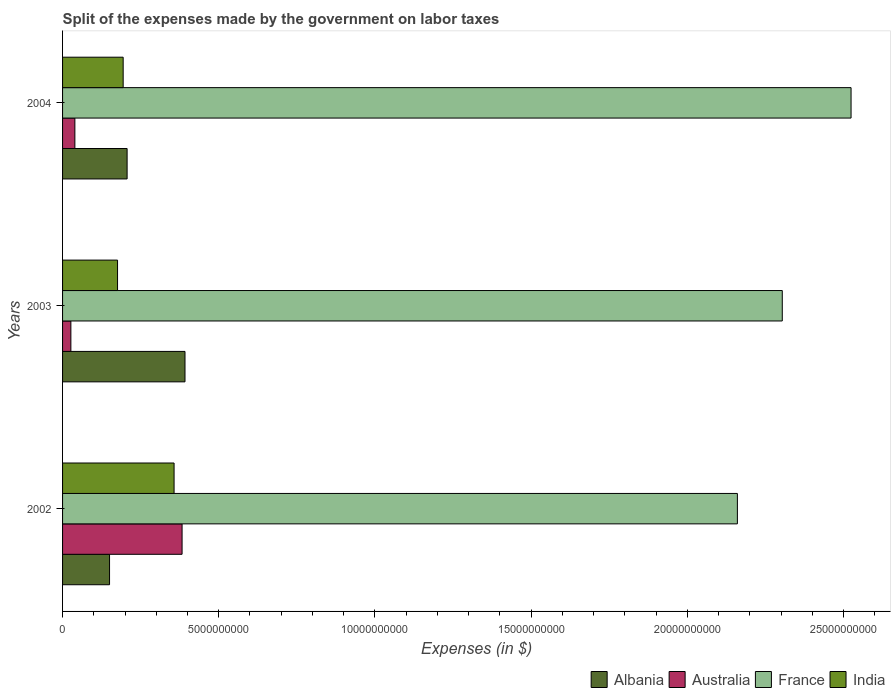How many different coloured bars are there?
Provide a short and direct response. 4. Are the number of bars per tick equal to the number of legend labels?
Offer a very short reply. Yes. Are the number of bars on each tick of the Y-axis equal?
Your response must be concise. Yes. How many bars are there on the 2nd tick from the bottom?
Offer a terse response. 4. What is the label of the 2nd group of bars from the top?
Offer a terse response. 2003. In how many cases, is the number of bars for a given year not equal to the number of legend labels?
Your answer should be compact. 0. What is the expenses made by the government on labor taxes in France in 2002?
Give a very brief answer. 2.16e+1. Across all years, what is the maximum expenses made by the government on labor taxes in France?
Offer a terse response. 2.52e+1. Across all years, what is the minimum expenses made by the government on labor taxes in Albania?
Your answer should be compact. 1.50e+09. In which year was the expenses made by the government on labor taxes in India maximum?
Ensure brevity in your answer.  2002. In which year was the expenses made by the government on labor taxes in Albania minimum?
Provide a short and direct response. 2002. What is the total expenses made by the government on labor taxes in Albania in the graph?
Ensure brevity in your answer.  7.49e+09. What is the difference between the expenses made by the government on labor taxes in India in 2002 and that in 2003?
Ensure brevity in your answer.  1.81e+09. What is the difference between the expenses made by the government on labor taxes in Australia in 2004 and the expenses made by the government on labor taxes in Albania in 2003?
Give a very brief answer. -3.53e+09. What is the average expenses made by the government on labor taxes in Albania per year?
Give a very brief answer. 2.50e+09. In the year 2002, what is the difference between the expenses made by the government on labor taxes in Albania and expenses made by the government on labor taxes in France?
Make the answer very short. -2.01e+1. In how many years, is the expenses made by the government on labor taxes in Albania greater than 17000000000 $?
Ensure brevity in your answer.  0. What is the ratio of the expenses made by the government on labor taxes in Australia in 2003 to that in 2004?
Ensure brevity in your answer.  0.68. Is the difference between the expenses made by the government on labor taxes in Albania in 2002 and 2003 greater than the difference between the expenses made by the government on labor taxes in France in 2002 and 2003?
Provide a short and direct response. No. What is the difference between the highest and the second highest expenses made by the government on labor taxes in Albania?
Your answer should be very brief. 1.85e+09. What is the difference between the highest and the lowest expenses made by the government on labor taxes in Australia?
Offer a very short reply. 3.56e+09. Is the sum of the expenses made by the government on labor taxes in Albania in 2003 and 2004 greater than the maximum expenses made by the government on labor taxes in Australia across all years?
Your answer should be compact. Yes. Is it the case that in every year, the sum of the expenses made by the government on labor taxes in India and expenses made by the government on labor taxes in France is greater than the sum of expenses made by the government on labor taxes in Australia and expenses made by the government on labor taxes in Albania?
Your answer should be compact. No. What does the 4th bar from the top in 2002 represents?
Your answer should be very brief. Albania. What does the 3rd bar from the bottom in 2002 represents?
Offer a terse response. France. How many bars are there?
Offer a very short reply. 12. How many years are there in the graph?
Provide a succinct answer. 3. What is the difference between two consecutive major ticks on the X-axis?
Provide a succinct answer. 5.00e+09. Are the values on the major ticks of X-axis written in scientific E-notation?
Provide a short and direct response. No. Does the graph contain any zero values?
Keep it short and to the point. No. Does the graph contain grids?
Your answer should be very brief. No. Where does the legend appear in the graph?
Make the answer very short. Bottom right. How many legend labels are there?
Make the answer very short. 4. How are the legend labels stacked?
Your answer should be compact. Horizontal. What is the title of the graph?
Provide a short and direct response. Split of the expenses made by the government on labor taxes. Does "Nicaragua" appear as one of the legend labels in the graph?
Provide a succinct answer. No. What is the label or title of the X-axis?
Ensure brevity in your answer.  Expenses (in $). What is the label or title of the Y-axis?
Ensure brevity in your answer.  Years. What is the Expenses (in $) of Albania in 2002?
Offer a very short reply. 1.50e+09. What is the Expenses (in $) in Australia in 2002?
Your response must be concise. 3.83e+09. What is the Expenses (in $) of France in 2002?
Give a very brief answer. 2.16e+1. What is the Expenses (in $) of India in 2002?
Your answer should be very brief. 3.57e+09. What is the Expenses (in $) in Albania in 2003?
Offer a terse response. 3.92e+09. What is the Expenses (in $) of Australia in 2003?
Your answer should be very brief. 2.66e+08. What is the Expenses (in $) of France in 2003?
Your response must be concise. 2.30e+1. What is the Expenses (in $) of India in 2003?
Ensure brevity in your answer.  1.76e+09. What is the Expenses (in $) in Albania in 2004?
Ensure brevity in your answer.  2.07e+09. What is the Expenses (in $) of Australia in 2004?
Offer a very short reply. 3.94e+08. What is the Expenses (in $) in France in 2004?
Your response must be concise. 2.52e+1. What is the Expenses (in $) in India in 2004?
Provide a short and direct response. 1.94e+09. Across all years, what is the maximum Expenses (in $) in Albania?
Offer a very short reply. 3.92e+09. Across all years, what is the maximum Expenses (in $) of Australia?
Ensure brevity in your answer.  3.83e+09. Across all years, what is the maximum Expenses (in $) in France?
Offer a very short reply. 2.52e+1. Across all years, what is the maximum Expenses (in $) of India?
Your answer should be compact. 3.57e+09. Across all years, what is the minimum Expenses (in $) in Albania?
Your response must be concise. 1.50e+09. Across all years, what is the minimum Expenses (in $) in Australia?
Offer a very short reply. 2.66e+08. Across all years, what is the minimum Expenses (in $) in France?
Your response must be concise. 2.16e+1. Across all years, what is the minimum Expenses (in $) of India?
Ensure brevity in your answer.  1.76e+09. What is the total Expenses (in $) in Albania in the graph?
Give a very brief answer. 7.49e+09. What is the total Expenses (in $) of Australia in the graph?
Your response must be concise. 4.49e+09. What is the total Expenses (in $) in France in the graph?
Offer a very short reply. 6.99e+1. What is the total Expenses (in $) in India in the graph?
Your answer should be compact. 7.27e+09. What is the difference between the Expenses (in $) of Albania in 2002 and that in 2003?
Offer a very short reply. -2.42e+09. What is the difference between the Expenses (in $) of Australia in 2002 and that in 2003?
Your answer should be compact. 3.56e+09. What is the difference between the Expenses (in $) of France in 2002 and that in 2003?
Give a very brief answer. -1.44e+09. What is the difference between the Expenses (in $) in India in 2002 and that in 2003?
Your response must be concise. 1.81e+09. What is the difference between the Expenses (in $) of Albania in 2002 and that in 2004?
Make the answer very short. -5.62e+08. What is the difference between the Expenses (in $) in Australia in 2002 and that in 2004?
Provide a short and direct response. 3.43e+09. What is the difference between the Expenses (in $) of France in 2002 and that in 2004?
Keep it short and to the point. -3.64e+09. What is the difference between the Expenses (in $) in India in 2002 and that in 2004?
Your answer should be compact. 1.63e+09. What is the difference between the Expenses (in $) of Albania in 2003 and that in 2004?
Your response must be concise. 1.85e+09. What is the difference between the Expenses (in $) in Australia in 2003 and that in 2004?
Provide a short and direct response. -1.28e+08. What is the difference between the Expenses (in $) in France in 2003 and that in 2004?
Provide a short and direct response. -2.20e+09. What is the difference between the Expenses (in $) of India in 2003 and that in 2004?
Keep it short and to the point. -1.80e+08. What is the difference between the Expenses (in $) of Albania in 2002 and the Expenses (in $) of Australia in 2003?
Offer a terse response. 1.24e+09. What is the difference between the Expenses (in $) of Albania in 2002 and the Expenses (in $) of France in 2003?
Give a very brief answer. -2.15e+1. What is the difference between the Expenses (in $) of Albania in 2002 and the Expenses (in $) of India in 2003?
Offer a very short reply. -2.56e+08. What is the difference between the Expenses (in $) of Australia in 2002 and the Expenses (in $) of France in 2003?
Keep it short and to the point. -1.92e+1. What is the difference between the Expenses (in $) in Australia in 2002 and the Expenses (in $) in India in 2003?
Make the answer very short. 2.07e+09. What is the difference between the Expenses (in $) of France in 2002 and the Expenses (in $) of India in 2003?
Your answer should be compact. 1.98e+1. What is the difference between the Expenses (in $) in Albania in 2002 and the Expenses (in $) in Australia in 2004?
Give a very brief answer. 1.11e+09. What is the difference between the Expenses (in $) of Albania in 2002 and the Expenses (in $) of France in 2004?
Ensure brevity in your answer.  -2.37e+1. What is the difference between the Expenses (in $) in Albania in 2002 and the Expenses (in $) in India in 2004?
Make the answer very short. -4.36e+08. What is the difference between the Expenses (in $) in Australia in 2002 and the Expenses (in $) in France in 2004?
Your response must be concise. -2.14e+1. What is the difference between the Expenses (in $) in Australia in 2002 and the Expenses (in $) in India in 2004?
Give a very brief answer. 1.89e+09. What is the difference between the Expenses (in $) of France in 2002 and the Expenses (in $) of India in 2004?
Your answer should be compact. 1.97e+1. What is the difference between the Expenses (in $) of Albania in 2003 and the Expenses (in $) of Australia in 2004?
Provide a short and direct response. 3.53e+09. What is the difference between the Expenses (in $) in Albania in 2003 and the Expenses (in $) in France in 2004?
Provide a succinct answer. -2.13e+1. What is the difference between the Expenses (in $) in Albania in 2003 and the Expenses (in $) in India in 2004?
Your response must be concise. 1.98e+09. What is the difference between the Expenses (in $) of Australia in 2003 and the Expenses (in $) of France in 2004?
Provide a succinct answer. -2.50e+1. What is the difference between the Expenses (in $) in Australia in 2003 and the Expenses (in $) in India in 2004?
Keep it short and to the point. -1.67e+09. What is the difference between the Expenses (in $) in France in 2003 and the Expenses (in $) in India in 2004?
Provide a succinct answer. 2.11e+1. What is the average Expenses (in $) of Albania per year?
Ensure brevity in your answer.  2.50e+09. What is the average Expenses (in $) in Australia per year?
Provide a succinct answer. 1.50e+09. What is the average Expenses (in $) in France per year?
Offer a very short reply. 2.33e+1. What is the average Expenses (in $) in India per year?
Your response must be concise. 2.42e+09. In the year 2002, what is the difference between the Expenses (in $) of Albania and Expenses (in $) of Australia?
Provide a short and direct response. -2.32e+09. In the year 2002, what is the difference between the Expenses (in $) of Albania and Expenses (in $) of France?
Your response must be concise. -2.01e+1. In the year 2002, what is the difference between the Expenses (in $) in Albania and Expenses (in $) in India?
Keep it short and to the point. -2.07e+09. In the year 2002, what is the difference between the Expenses (in $) in Australia and Expenses (in $) in France?
Offer a very short reply. -1.78e+1. In the year 2002, what is the difference between the Expenses (in $) of Australia and Expenses (in $) of India?
Offer a terse response. 2.56e+08. In the year 2002, what is the difference between the Expenses (in $) in France and Expenses (in $) in India?
Give a very brief answer. 1.80e+1. In the year 2003, what is the difference between the Expenses (in $) of Albania and Expenses (in $) of Australia?
Provide a succinct answer. 3.65e+09. In the year 2003, what is the difference between the Expenses (in $) of Albania and Expenses (in $) of France?
Your answer should be very brief. -1.91e+1. In the year 2003, what is the difference between the Expenses (in $) in Albania and Expenses (in $) in India?
Provide a succinct answer. 2.16e+09. In the year 2003, what is the difference between the Expenses (in $) of Australia and Expenses (in $) of France?
Keep it short and to the point. -2.28e+1. In the year 2003, what is the difference between the Expenses (in $) in Australia and Expenses (in $) in India?
Give a very brief answer. -1.49e+09. In the year 2003, what is the difference between the Expenses (in $) in France and Expenses (in $) in India?
Offer a very short reply. 2.13e+1. In the year 2004, what is the difference between the Expenses (in $) of Albania and Expenses (in $) of Australia?
Your answer should be very brief. 1.67e+09. In the year 2004, what is the difference between the Expenses (in $) of Albania and Expenses (in $) of France?
Keep it short and to the point. -2.32e+1. In the year 2004, what is the difference between the Expenses (in $) of Albania and Expenses (in $) of India?
Your answer should be compact. 1.26e+08. In the year 2004, what is the difference between the Expenses (in $) in Australia and Expenses (in $) in France?
Offer a very short reply. -2.48e+1. In the year 2004, what is the difference between the Expenses (in $) in Australia and Expenses (in $) in India?
Provide a short and direct response. -1.55e+09. In the year 2004, what is the difference between the Expenses (in $) in France and Expenses (in $) in India?
Make the answer very short. 2.33e+1. What is the ratio of the Expenses (in $) of Albania in 2002 to that in 2003?
Give a very brief answer. 0.38. What is the ratio of the Expenses (in $) in Australia in 2002 to that in 2003?
Provide a short and direct response. 14.38. What is the ratio of the Expenses (in $) in France in 2002 to that in 2003?
Provide a short and direct response. 0.94. What is the ratio of the Expenses (in $) of India in 2002 to that in 2003?
Your response must be concise. 2.03. What is the ratio of the Expenses (in $) of Albania in 2002 to that in 2004?
Give a very brief answer. 0.73. What is the ratio of the Expenses (in $) of Australia in 2002 to that in 2004?
Ensure brevity in your answer.  9.71. What is the ratio of the Expenses (in $) of France in 2002 to that in 2004?
Give a very brief answer. 0.86. What is the ratio of the Expenses (in $) in India in 2002 to that in 2004?
Make the answer very short. 1.84. What is the ratio of the Expenses (in $) in Albania in 2003 to that in 2004?
Give a very brief answer. 1.9. What is the ratio of the Expenses (in $) in Australia in 2003 to that in 2004?
Keep it short and to the point. 0.68. What is the ratio of the Expenses (in $) in France in 2003 to that in 2004?
Keep it short and to the point. 0.91. What is the ratio of the Expenses (in $) in India in 2003 to that in 2004?
Give a very brief answer. 0.91. What is the difference between the highest and the second highest Expenses (in $) of Albania?
Keep it short and to the point. 1.85e+09. What is the difference between the highest and the second highest Expenses (in $) of Australia?
Make the answer very short. 3.43e+09. What is the difference between the highest and the second highest Expenses (in $) in France?
Your response must be concise. 2.20e+09. What is the difference between the highest and the second highest Expenses (in $) of India?
Your answer should be compact. 1.63e+09. What is the difference between the highest and the lowest Expenses (in $) of Albania?
Keep it short and to the point. 2.42e+09. What is the difference between the highest and the lowest Expenses (in $) of Australia?
Your answer should be very brief. 3.56e+09. What is the difference between the highest and the lowest Expenses (in $) of France?
Offer a very short reply. 3.64e+09. What is the difference between the highest and the lowest Expenses (in $) in India?
Your answer should be very brief. 1.81e+09. 